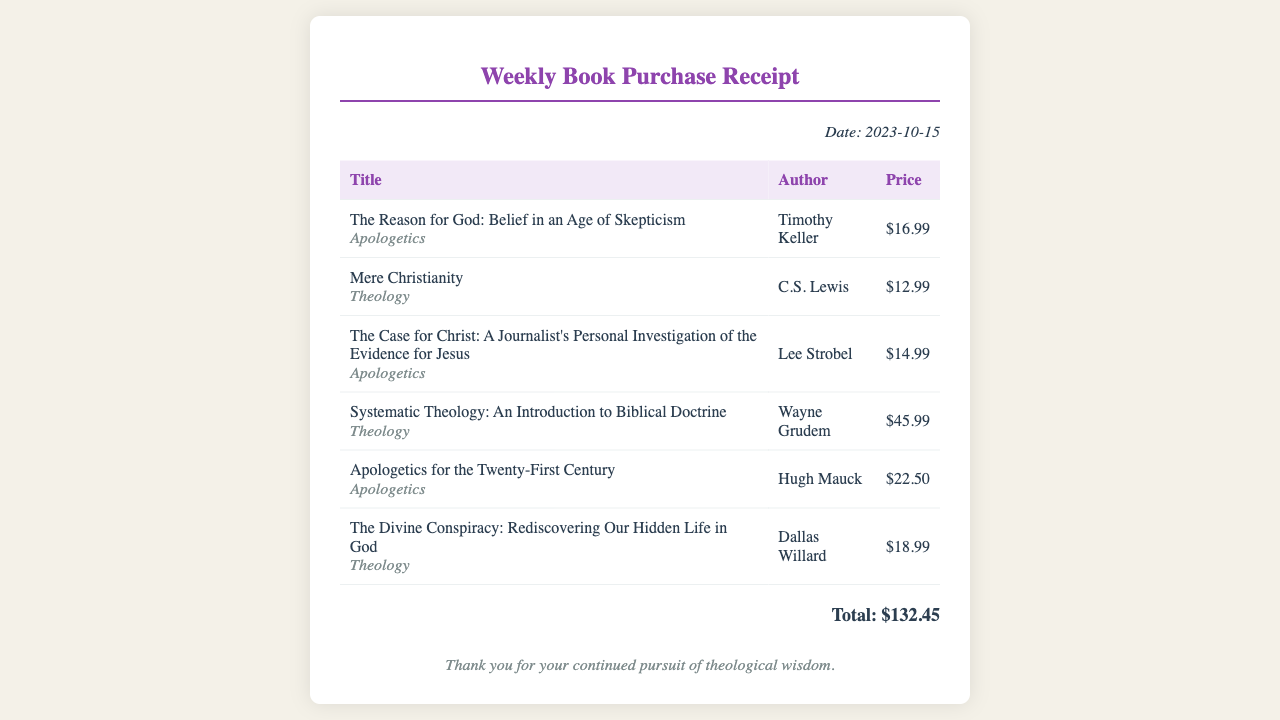What is the date of the receipt? The date is explicitly stated at the top of the receipt.
Answer: 2023-10-15 Who is the author of "The Reason for God"? The author's name is listed next to the title of the book in the receipt.
Answer: Timothy Keller What category does "Mere Christianity" belong to? The category of the book is specified below the title in the document.
Answer: Theology How much does "The Case for Christ" cost? The price is displayed in the table next to the book title.
Answer: $14.99 What is the total amount spent on books? The total amount is summarized at the bottom of the receipt.
Answer: $132.45 Which book is authored by C.S. Lewis? The document reveals that C.S. Lewis authored "Mere Christianity."
Answer: Mere Christianity How many apologetics books are listed? The count can be determined by reviewing the rows marked with the "Apologetics" category.
Answer: 3 What is the signature message at the bottom of the receipt? The signature provides a closing statement related to the purchase.
Answer: Thank you for your continued pursuit of theological wisdom Which book is the most expensive? The price comparisons of the listed books will show the highest price.
Answer: Systematic Theology: An Introduction to Biblical Doctrine 